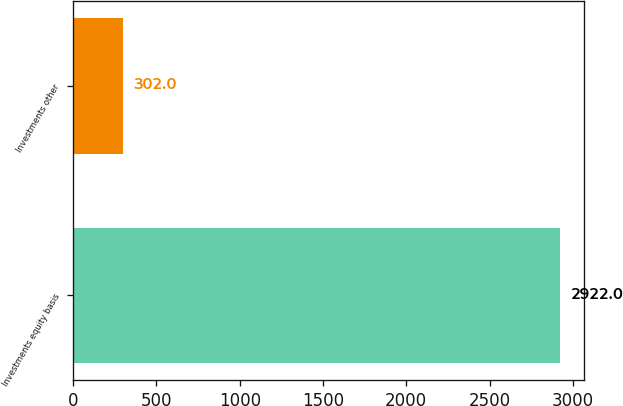<chart> <loc_0><loc_0><loc_500><loc_500><bar_chart><fcel>Investments equity basis<fcel>Investments other<nl><fcel>2922<fcel>302<nl></chart> 